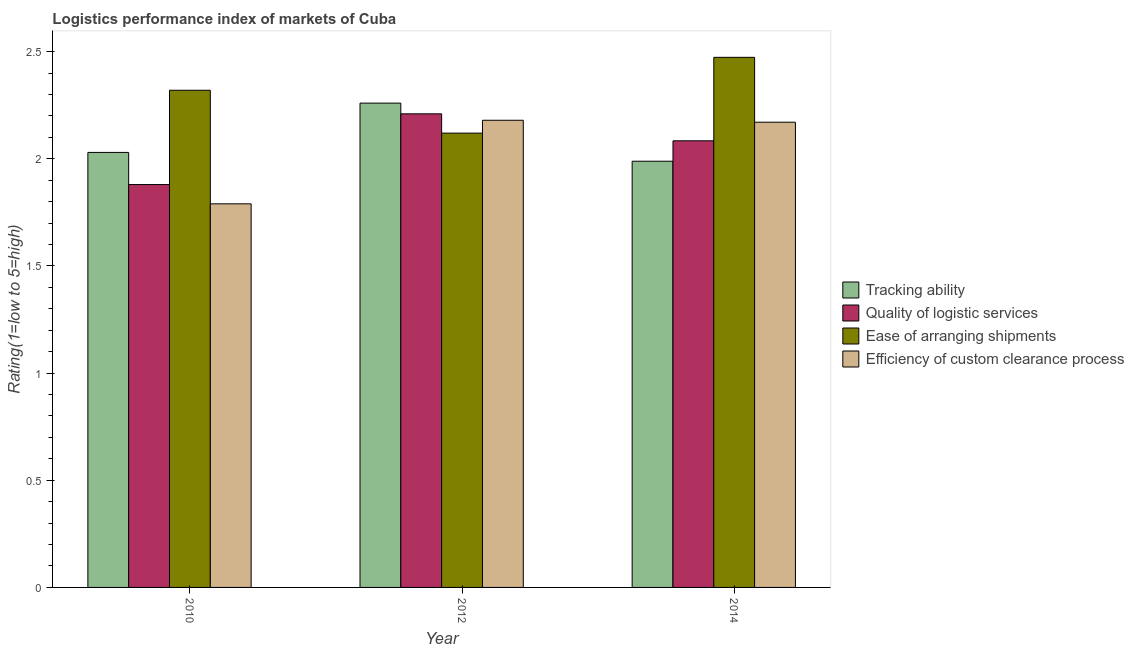How many different coloured bars are there?
Keep it short and to the point. 4. How many groups of bars are there?
Offer a terse response. 3. Are the number of bars per tick equal to the number of legend labels?
Offer a very short reply. Yes. Are the number of bars on each tick of the X-axis equal?
Keep it short and to the point. Yes. How many bars are there on the 1st tick from the left?
Your response must be concise. 4. How many bars are there on the 1st tick from the right?
Your answer should be compact. 4. What is the lpi rating of ease of arranging shipments in 2010?
Offer a very short reply. 2.32. Across all years, what is the maximum lpi rating of quality of logistic services?
Ensure brevity in your answer.  2.21. Across all years, what is the minimum lpi rating of quality of logistic services?
Provide a succinct answer. 1.88. In which year was the lpi rating of tracking ability maximum?
Ensure brevity in your answer.  2012. What is the total lpi rating of ease of arranging shipments in the graph?
Keep it short and to the point. 6.91. What is the difference between the lpi rating of quality of logistic services in 2010 and that in 2012?
Offer a very short reply. -0.33. What is the difference between the lpi rating of tracking ability in 2014 and the lpi rating of quality of logistic services in 2012?
Give a very brief answer. -0.27. What is the average lpi rating of efficiency of custom clearance process per year?
Provide a succinct answer. 2.05. In the year 2012, what is the difference between the lpi rating of efficiency of custom clearance process and lpi rating of tracking ability?
Offer a very short reply. 0. In how many years, is the lpi rating of tracking ability greater than 0.8?
Provide a succinct answer. 3. What is the ratio of the lpi rating of efficiency of custom clearance process in 2010 to that in 2014?
Your response must be concise. 0.82. Is the lpi rating of efficiency of custom clearance process in 2010 less than that in 2014?
Offer a terse response. Yes. What is the difference between the highest and the second highest lpi rating of quality of logistic services?
Provide a short and direct response. 0.13. What is the difference between the highest and the lowest lpi rating of tracking ability?
Ensure brevity in your answer.  0.27. In how many years, is the lpi rating of quality of logistic services greater than the average lpi rating of quality of logistic services taken over all years?
Offer a terse response. 2. Is the sum of the lpi rating of quality of logistic services in 2010 and 2012 greater than the maximum lpi rating of ease of arranging shipments across all years?
Give a very brief answer. Yes. What does the 3rd bar from the left in 2010 represents?
Ensure brevity in your answer.  Ease of arranging shipments. What does the 4th bar from the right in 2012 represents?
Make the answer very short. Tracking ability. Are all the bars in the graph horizontal?
Offer a very short reply. No. How many years are there in the graph?
Keep it short and to the point. 3. What is the difference between two consecutive major ticks on the Y-axis?
Offer a terse response. 0.5. Does the graph contain any zero values?
Keep it short and to the point. No. Does the graph contain grids?
Your answer should be compact. No. Where does the legend appear in the graph?
Provide a short and direct response. Center right. How many legend labels are there?
Your answer should be very brief. 4. What is the title of the graph?
Your answer should be very brief. Logistics performance index of markets of Cuba. What is the label or title of the X-axis?
Your response must be concise. Year. What is the label or title of the Y-axis?
Give a very brief answer. Rating(1=low to 5=high). What is the Rating(1=low to 5=high) in Tracking ability in 2010?
Keep it short and to the point. 2.03. What is the Rating(1=low to 5=high) of Quality of logistic services in 2010?
Your response must be concise. 1.88. What is the Rating(1=low to 5=high) in Ease of arranging shipments in 2010?
Offer a terse response. 2.32. What is the Rating(1=low to 5=high) in Efficiency of custom clearance process in 2010?
Your response must be concise. 1.79. What is the Rating(1=low to 5=high) in Tracking ability in 2012?
Provide a succinct answer. 2.26. What is the Rating(1=low to 5=high) in Quality of logistic services in 2012?
Provide a succinct answer. 2.21. What is the Rating(1=low to 5=high) in Ease of arranging shipments in 2012?
Provide a succinct answer. 2.12. What is the Rating(1=low to 5=high) of Efficiency of custom clearance process in 2012?
Keep it short and to the point. 2.18. What is the Rating(1=low to 5=high) of Tracking ability in 2014?
Your response must be concise. 1.99. What is the Rating(1=low to 5=high) in Quality of logistic services in 2014?
Offer a terse response. 2.08. What is the Rating(1=low to 5=high) of Ease of arranging shipments in 2014?
Make the answer very short. 2.47. What is the Rating(1=low to 5=high) in Efficiency of custom clearance process in 2014?
Make the answer very short. 2.17. Across all years, what is the maximum Rating(1=low to 5=high) of Tracking ability?
Give a very brief answer. 2.26. Across all years, what is the maximum Rating(1=low to 5=high) in Quality of logistic services?
Offer a terse response. 2.21. Across all years, what is the maximum Rating(1=low to 5=high) of Ease of arranging shipments?
Offer a very short reply. 2.47. Across all years, what is the maximum Rating(1=low to 5=high) in Efficiency of custom clearance process?
Offer a terse response. 2.18. Across all years, what is the minimum Rating(1=low to 5=high) of Tracking ability?
Offer a terse response. 1.99. Across all years, what is the minimum Rating(1=low to 5=high) of Quality of logistic services?
Give a very brief answer. 1.88. Across all years, what is the minimum Rating(1=low to 5=high) of Ease of arranging shipments?
Provide a short and direct response. 2.12. Across all years, what is the minimum Rating(1=low to 5=high) in Efficiency of custom clearance process?
Give a very brief answer. 1.79. What is the total Rating(1=low to 5=high) in Tracking ability in the graph?
Offer a terse response. 6.28. What is the total Rating(1=low to 5=high) in Quality of logistic services in the graph?
Offer a very short reply. 6.17. What is the total Rating(1=low to 5=high) of Ease of arranging shipments in the graph?
Give a very brief answer. 6.91. What is the total Rating(1=low to 5=high) in Efficiency of custom clearance process in the graph?
Offer a very short reply. 6.14. What is the difference between the Rating(1=low to 5=high) of Tracking ability in 2010 and that in 2012?
Make the answer very short. -0.23. What is the difference between the Rating(1=low to 5=high) in Quality of logistic services in 2010 and that in 2012?
Your response must be concise. -0.33. What is the difference between the Rating(1=low to 5=high) in Efficiency of custom clearance process in 2010 and that in 2012?
Offer a very short reply. -0.39. What is the difference between the Rating(1=low to 5=high) in Tracking ability in 2010 and that in 2014?
Provide a succinct answer. 0.04. What is the difference between the Rating(1=low to 5=high) in Quality of logistic services in 2010 and that in 2014?
Make the answer very short. -0.2. What is the difference between the Rating(1=low to 5=high) of Ease of arranging shipments in 2010 and that in 2014?
Give a very brief answer. -0.15. What is the difference between the Rating(1=low to 5=high) of Efficiency of custom clearance process in 2010 and that in 2014?
Your answer should be compact. -0.38. What is the difference between the Rating(1=low to 5=high) in Tracking ability in 2012 and that in 2014?
Your answer should be compact. 0.27. What is the difference between the Rating(1=low to 5=high) of Quality of logistic services in 2012 and that in 2014?
Offer a terse response. 0.13. What is the difference between the Rating(1=low to 5=high) in Ease of arranging shipments in 2012 and that in 2014?
Your answer should be compact. -0.35. What is the difference between the Rating(1=low to 5=high) in Efficiency of custom clearance process in 2012 and that in 2014?
Offer a terse response. 0.01. What is the difference between the Rating(1=low to 5=high) of Tracking ability in 2010 and the Rating(1=low to 5=high) of Quality of logistic services in 2012?
Give a very brief answer. -0.18. What is the difference between the Rating(1=low to 5=high) in Tracking ability in 2010 and the Rating(1=low to 5=high) in Ease of arranging shipments in 2012?
Offer a terse response. -0.09. What is the difference between the Rating(1=low to 5=high) of Tracking ability in 2010 and the Rating(1=low to 5=high) of Efficiency of custom clearance process in 2012?
Offer a terse response. -0.15. What is the difference between the Rating(1=low to 5=high) of Quality of logistic services in 2010 and the Rating(1=low to 5=high) of Ease of arranging shipments in 2012?
Offer a terse response. -0.24. What is the difference between the Rating(1=low to 5=high) in Ease of arranging shipments in 2010 and the Rating(1=low to 5=high) in Efficiency of custom clearance process in 2012?
Make the answer very short. 0.14. What is the difference between the Rating(1=low to 5=high) of Tracking ability in 2010 and the Rating(1=low to 5=high) of Quality of logistic services in 2014?
Give a very brief answer. -0.05. What is the difference between the Rating(1=low to 5=high) in Tracking ability in 2010 and the Rating(1=low to 5=high) in Ease of arranging shipments in 2014?
Offer a terse response. -0.44. What is the difference between the Rating(1=low to 5=high) of Tracking ability in 2010 and the Rating(1=low to 5=high) of Efficiency of custom clearance process in 2014?
Your answer should be very brief. -0.14. What is the difference between the Rating(1=low to 5=high) in Quality of logistic services in 2010 and the Rating(1=low to 5=high) in Ease of arranging shipments in 2014?
Offer a terse response. -0.59. What is the difference between the Rating(1=low to 5=high) in Quality of logistic services in 2010 and the Rating(1=low to 5=high) in Efficiency of custom clearance process in 2014?
Make the answer very short. -0.29. What is the difference between the Rating(1=low to 5=high) of Ease of arranging shipments in 2010 and the Rating(1=low to 5=high) of Efficiency of custom clearance process in 2014?
Offer a terse response. 0.15. What is the difference between the Rating(1=low to 5=high) in Tracking ability in 2012 and the Rating(1=low to 5=high) in Quality of logistic services in 2014?
Your response must be concise. 0.18. What is the difference between the Rating(1=low to 5=high) in Tracking ability in 2012 and the Rating(1=low to 5=high) in Ease of arranging shipments in 2014?
Keep it short and to the point. -0.21. What is the difference between the Rating(1=low to 5=high) of Tracking ability in 2012 and the Rating(1=low to 5=high) of Efficiency of custom clearance process in 2014?
Keep it short and to the point. 0.09. What is the difference between the Rating(1=low to 5=high) in Quality of logistic services in 2012 and the Rating(1=low to 5=high) in Ease of arranging shipments in 2014?
Your response must be concise. -0.26. What is the difference between the Rating(1=low to 5=high) of Quality of logistic services in 2012 and the Rating(1=low to 5=high) of Efficiency of custom clearance process in 2014?
Keep it short and to the point. 0.04. What is the difference between the Rating(1=low to 5=high) of Ease of arranging shipments in 2012 and the Rating(1=low to 5=high) of Efficiency of custom clearance process in 2014?
Your answer should be compact. -0.05. What is the average Rating(1=low to 5=high) of Tracking ability per year?
Give a very brief answer. 2.09. What is the average Rating(1=low to 5=high) in Quality of logistic services per year?
Offer a very short reply. 2.06. What is the average Rating(1=low to 5=high) in Ease of arranging shipments per year?
Your response must be concise. 2.3. What is the average Rating(1=low to 5=high) of Efficiency of custom clearance process per year?
Provide a succinct answer. 2.05. In the year 2010, what is the difference between the Rating(1=low to 5=high) in Tracking ability and Rating(1=low to 5=high) in Quality of logistic services?
Your answer should be compact. 0.15. In the year 2010, what is the difference between the Rating(1=low to 5=high) of Tracking ability and Rating(1=low to 5=high) of Ease of arranging shipments?
Provide a succinct answer. -0.29. In the year 2010, what is the difference between the Rating(1=low to 5=high) of Tracking ability and Rating(1=low to 5=high) of Efficiency of custom clearance process?
Provide a succinct answer. 0.24. In the year 2010, what is the difference between the Rating(1=low to 5=high) of Quality of logistic services and Rating(1=low to 5=high) of Ease of arranging shipments?
Your answer should be compact. -0.44. In the year 2010, what is the difference between the Rating(1=low to 5=high) in Quality of logistic services and Rating(1=low to 5=high) in Efficiency of custom clearance process?
Offer a very short reply. 0.09. In the year 2010, what is the difference between the Rating(1=low to 5=high) of Ease of arranging shipments and Rating(1=low to 5=high) of Efficiency of custom clearance process?
Offer a terse response. 0.53. In the year 2012, what is the difference between the Rating(1=low to 5=high) in Tracking ability and Rating(1=low to 5=high) in Ease of arranging shipments?
Give a very brief answer. 0.14. In the year 2012, what is the difference between the Rating(1=low to 5=high) in Tracking ability and Rating(1=low to 5=high) in Efficiency of custom clearance process?
Ensure brevity in your answer.  0.08. In the year 2012, what is the difference between the Rating(1=low to 5=high) in Quality of logistic services and Rating(1=low to 5=high) in Ease of arranging shipments?
Your answer should be compact. 0.09. In the year 2012, what is the difference between the Rating(1=low to 5=high) of Ease of arranging shipments and Rating(1=low to 5=high) of Efficiency of custom clearance process?
Offer a very short reply. -0.06. In the year 2014, what is the difference between the Rating(1=low to 5=high) in Tracking ability and Rating(1=low to 5=high) in Quality of logistic services?
Your answer should be compact. -0.1. In the year 2014, what is the difference between the Rating(1=low to 5=high) of Tracking ability and Rating(1=low to 5=high) of Ease of arranging shipments?
Your answer should be compact. -0.48. In the year 2014, what is the difference between the Rating(1=low to 5=high) of Tracking ability and Rating(1=low to 5=high) of Efficiency of custom clearance process?
Provide a succinct answer. -0.18. In the year 2014, what is the difference between the Rating(1=low to 5=high) of Quality of logistic services and Rating(1=low to 5=high) of Ease of arranging shipments?
Provide a succinct answer. -0.39. In the year 2014, what is the difference between the Rating(1=low to 5=high) in Quality of logistic services and Rating(1=low to 5=high) in Efficiency of custom clearance process?
Your answer should be very brief. -0.09. In the year 2014, what is the difference between the Rating(1=low to 5=high) in Ease of arranging shipments and Rating(1=low to 5=high) in Efficiency of custom clearance process?
Make the answer very short. 0.3. What is the ratio of the Rating(1=low to 5=high) in Tracking ability in 2010 to that in 2012?
Offer a terse response. 0.9. What is the ratio of the Rating(1=low to 5=high) in Quality of logistic services in 2010 to that in 2012?
Offer a very short reply. 0.85. What is the ratio of the Rating(1=low to 5=high) of Ease of arranging shipments in 2010 to that in 2012?
Make the answer very short. 1.09. What is the ratio of the Rating(1=low to 5=high) of Efficiency of custom clearance process in 2010 to that in 2012?
Ensure brevity in your answer.  0.82. What is the ratio of the Rating(1=low to 5=high) in Tracking ability in 2010 to that in 2014?
Offer a terse response. 1.02. What is the ratio of the Rating(1=low to 5=high) in Quality of logistic services in 2010 to that in 2014?
Provide a short and direct response. 0.9. What is the ratio of the Rating(1=low to 5=high) in Ease of arranging shipments in 2010 to that in 2014?
Keep it short and to the point. 0.94. What is the ratio of the Rating(1=low to 5=high) in Efficiency of custom clearance process in 2010 to that in 2014?
Ensure brevity in your answer.  0.82. What is the ratio of the Rating(1=low to 5=high) of Tracking ability in 2012 to that in 2014?
Offer a very short reply. 1.14. What is the ratio of the Rating(1=low to 5=high) of Quality of logistic services in 2012 to that in 2014?
Your answer should be very brief. 1.06. What is the ratio of the Rating(1=low to 5=high) in Ease of arranging shipments in 2012 to that in 2014?
Ensure brevity in your answer.  0.86. What is the difference between the highest and the second highest Rating(1=low to 5=high) of Tracking ability?
Provide a succinct answer. 0.23. What is the difference between the highest and the second highest Rating(1=low to 5=high) of Quality of logistic services?
Give a very brief answer. 0.13. What is the difference between the highest and the second highest Rating(1=low to 5=high) of Ease of arranging shipments?
Keep it short and to the point. 0.15. What is the difference between the highest and the second highest Rating(1=low to 5=high) of Efficiency of custom clearance process?
Offer a very short reply. 0.01. What is the difference between the highest and the lowest Rating(1=low to 5=high) in Tracking ability?
Provide a succinct answer. 0.27. What is the difference between the highest and the lowest Rating(1=low to 5=high) of Quality of logistic services?
Offer a terse response. 0.33. What is the difference between the highest and the lowest Rating(1=low to 5=high) in Ease of arranging shipments?
Provide a succinct answer. 0.35. What is the difference between the highest and the lowest Rating(1=low to 5=high) in Efficiency of custom clearance process?
Provide a succinct answer. 0.39. 